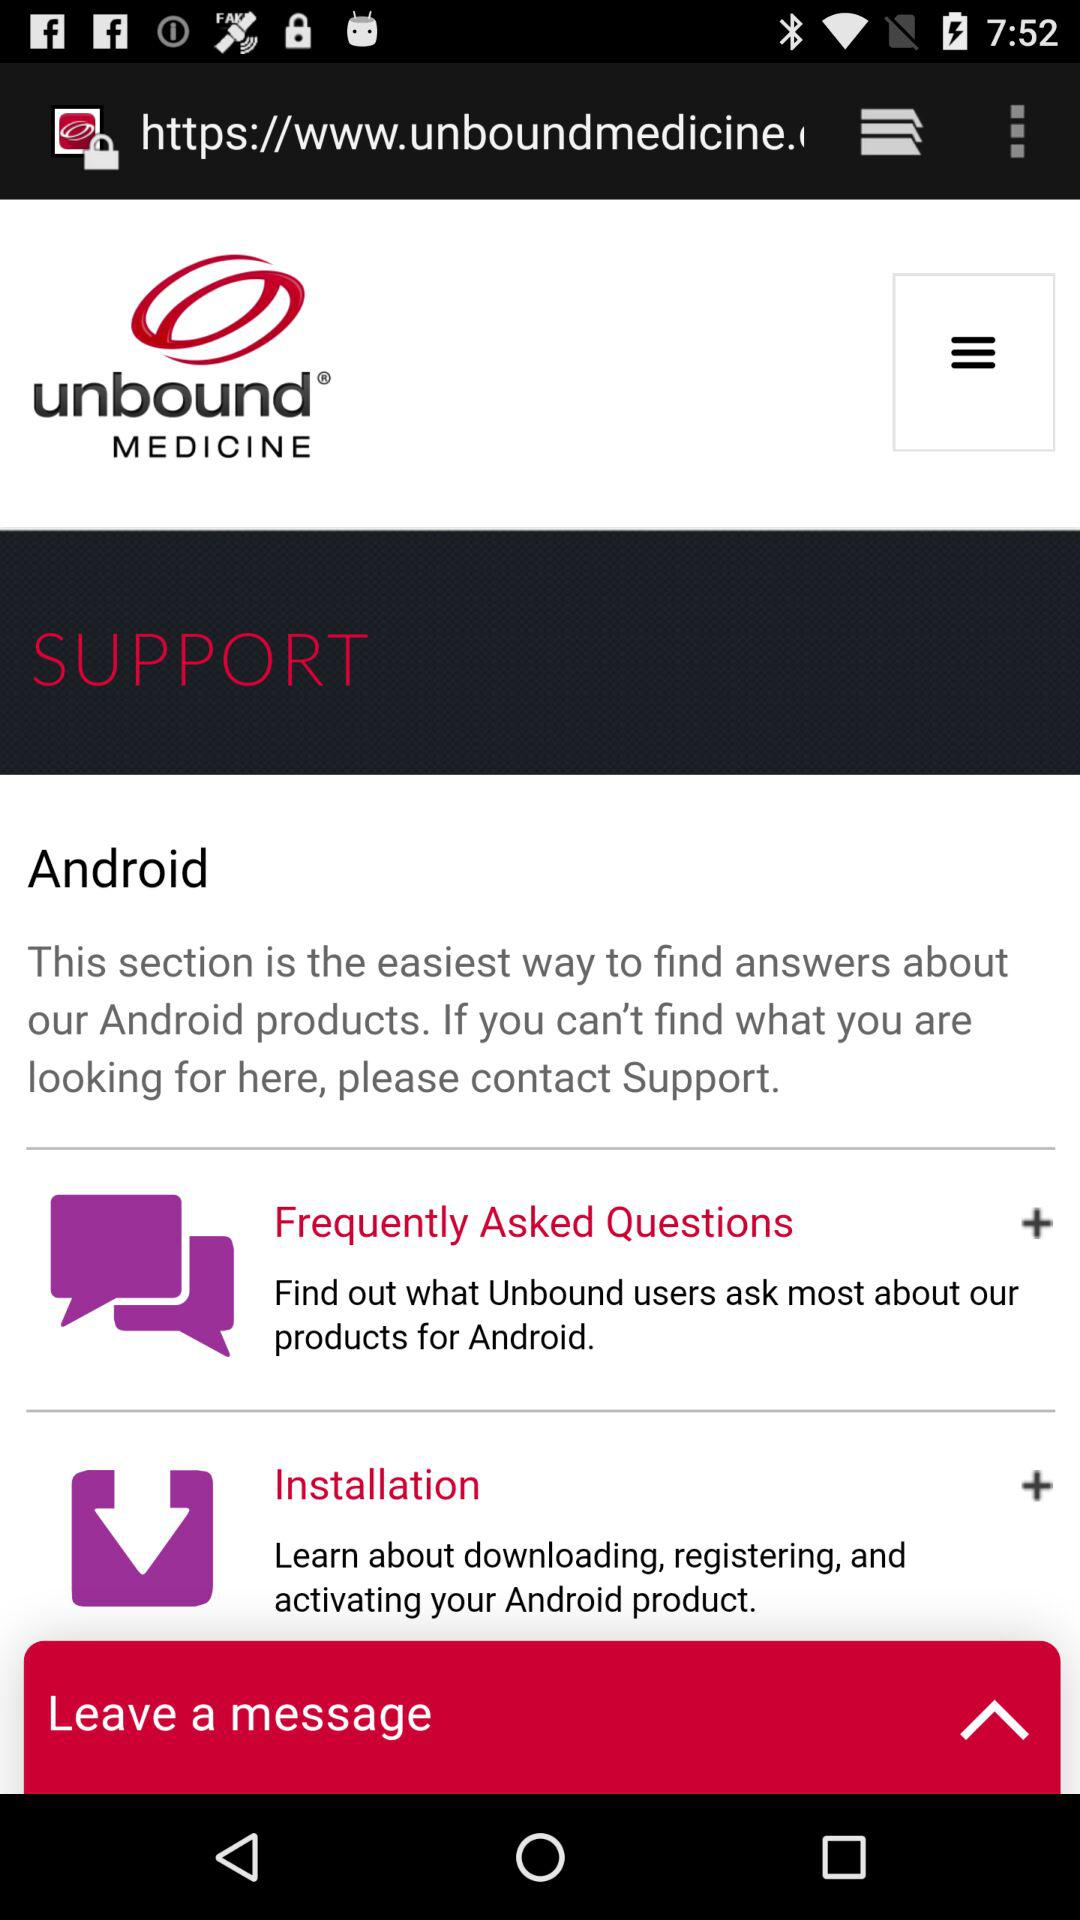Which questions are the most frequently asked?
When the provided information is insufficient, respond with <no answer>. <no answer> 